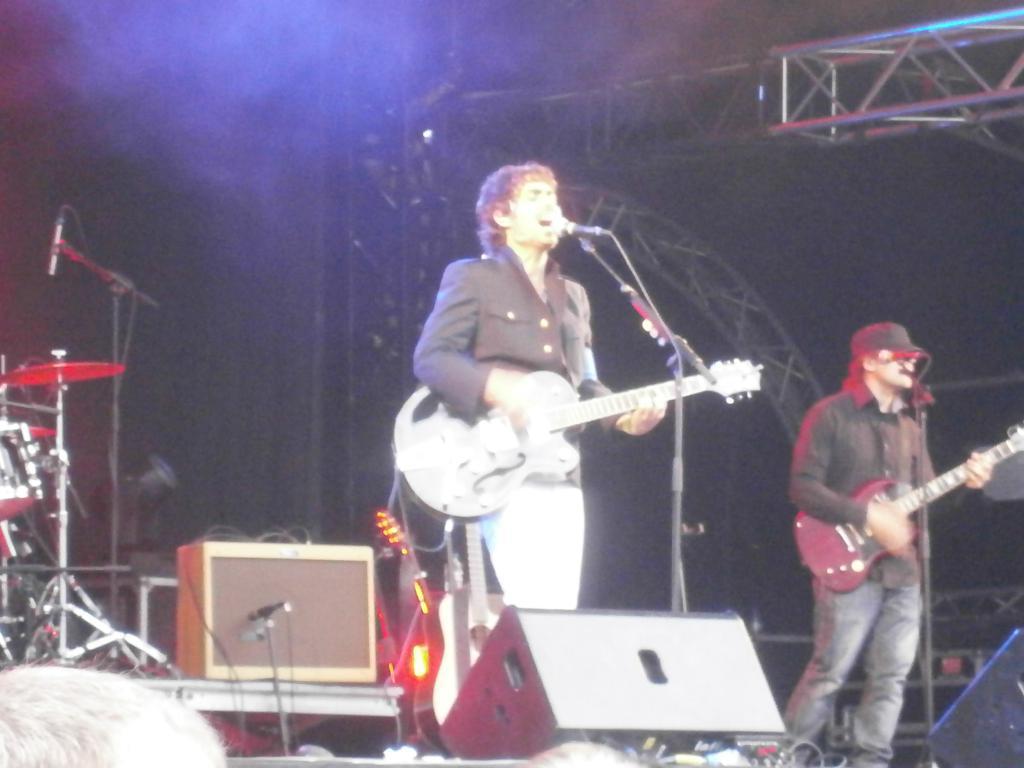Please provide a concise description of this image. This image consists of two persons playing guitar and singing. It looks like a concert. And we can see many musical instrument on the dais. In the front, there is a speaker. In the background, we can see a stand. 